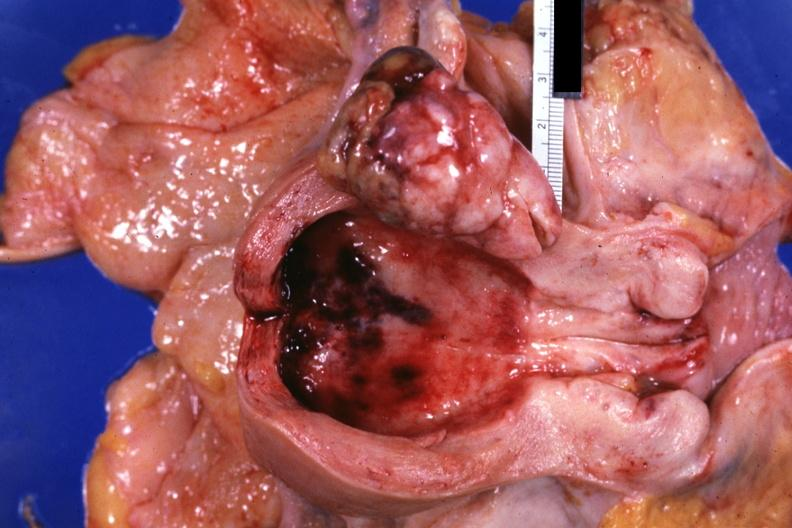does this image show opened uterus polypoid tumor demonstrated?
Answer the question using a single word or phrase. Yes 